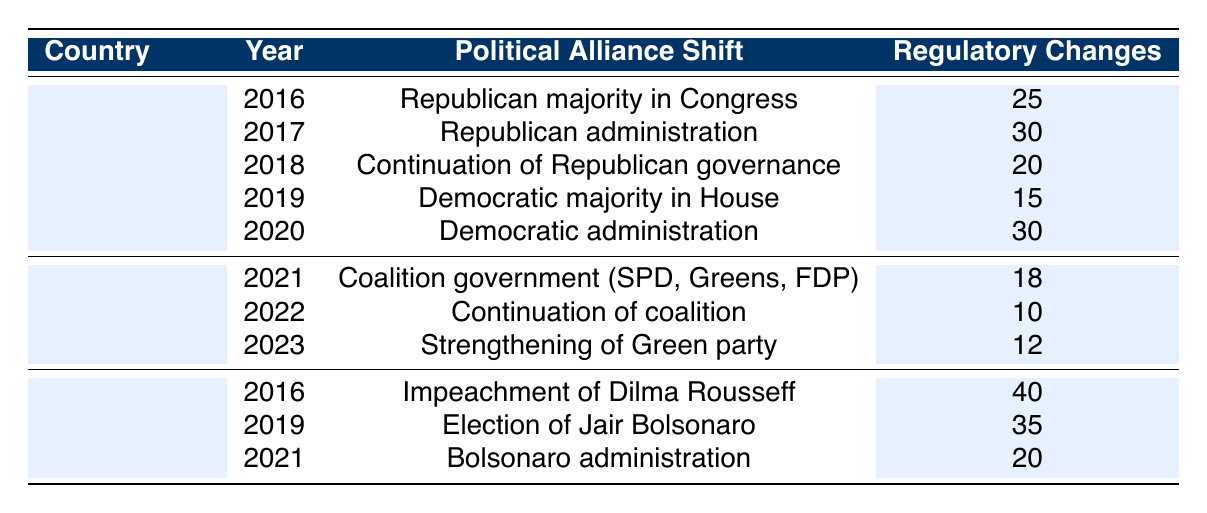What is the total number of regulatory changes in the United States from 2016 to 2020? To find the total, we add the regulatory changes for the years 2016 (25), 2017 (30), 2018 (20), 2019 (15), and 2020 (30). Thus, 25 + 30 + 20 + 15 + 30 = 130.
Answer: 130 In which year did Brazil experience the highest number of regulatory changes? By looking at the regulatory changes for Brazil across the given years, 2016 had 40, 2019 had 35, and 2021 had 20. Since 40 is the highest number, 2016 has the most regulatory changes.
Answer: 2016 Did Germany have more regulatory changes in 2021 than in 2023? In 2021, Germany had 18 regulatory changes, while in 2023 it had 12. Since 18 is greater than 12, the statement is true.
Answer: Yes What is the average number of regulatory changes in Brazil over the recorded years? Brazil has regulatory changes recorded for three years: 2016 (40), 2019 (35), and 2021 (20). Thus, the average = (40 + 35 + 20) / 3 = 95 / 3 = 31.67.
Answer: 31.67 What was the total number of regulatory changes in Germany between 2021 and 2023? The regulatory changes for Germany are: 2021 (18), 2022 (10), and 2023 (12). We sum these values: 18 + 10 + 12 = 40.
Answer: 40 